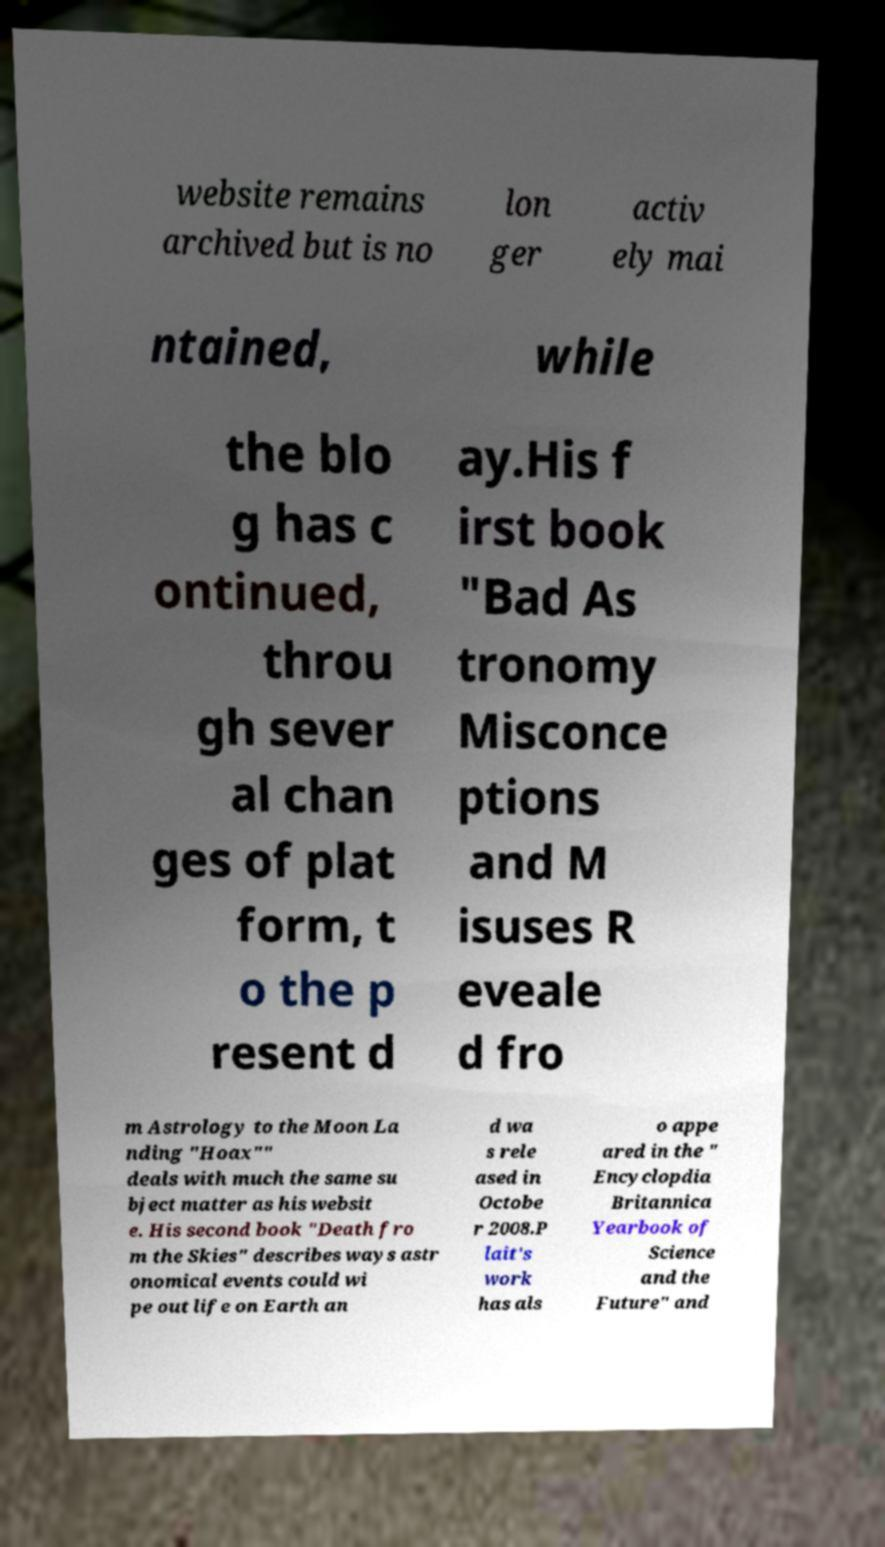Please read and relay the text visible in this image. What does it say? website remains archived but is no lon ger activ ely mai ntained, while the blo g has c ontinued, throu gh sever al chan ges of plat form, t o the p resent d ay.His f irst book "Bad As tronomy Misconce ptions and M isuses R eveale d fro m Astrology to the Moon La nding "Hoax"" deals with much the same su bject matter as his websit e. His second book "Death fro m the Skies" describes ways astr onomical events could wi pe out life on Earth an d wa s rele ased in Octobe r 2008.P lait's work has als o appe ared in the " Encyclopdia Britannica Yearbook of Science and the Future" and 